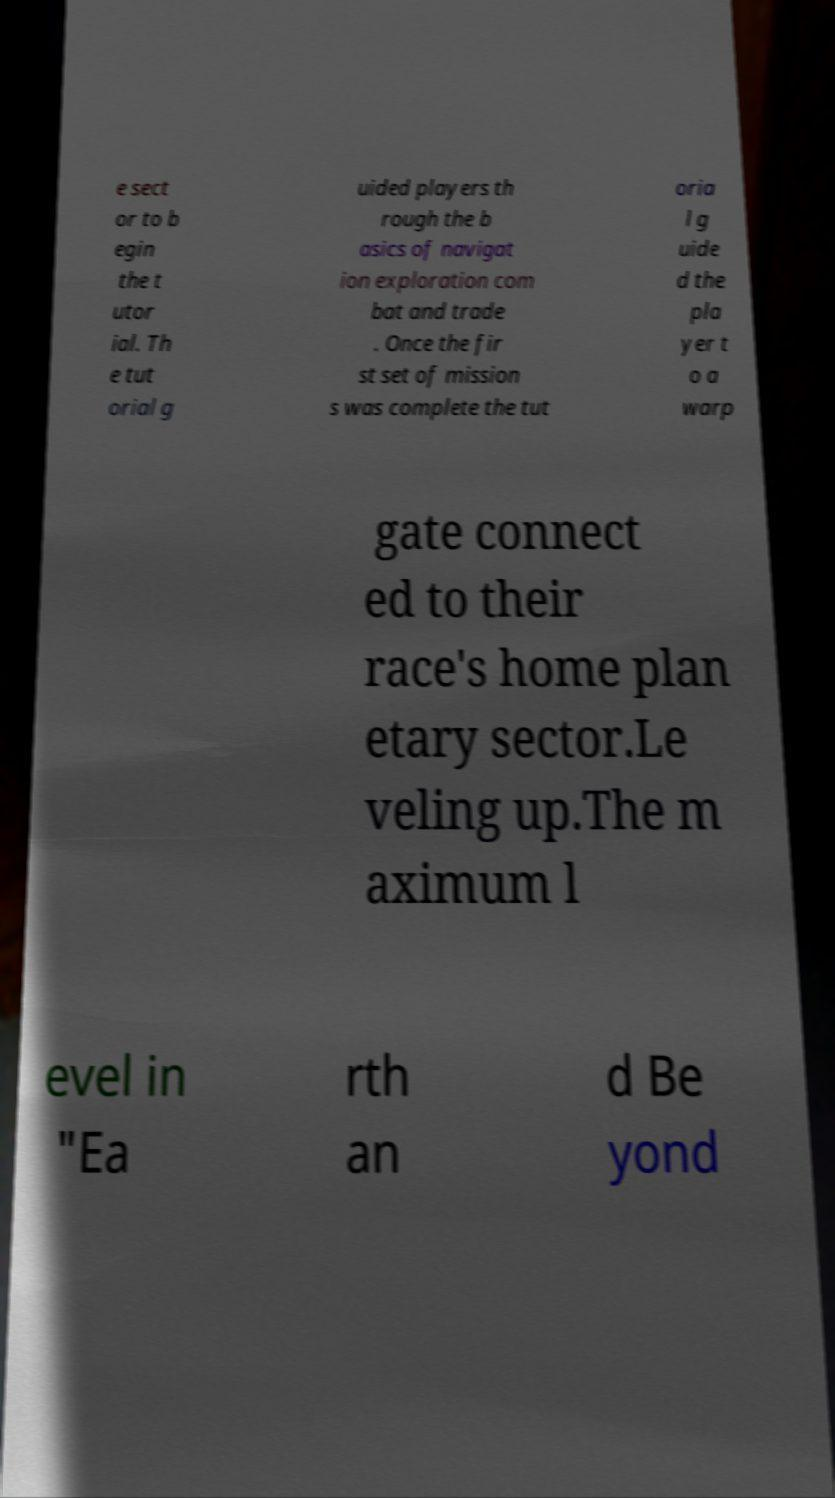I need the written content from this picture converted into text. Can you do that? e sect or to b egin the t utor ial. Th e tut orial g uided players th rough the b asics of navigat ion exploration com bat and trade . Once the fir st set of mission s was complete the tut oria l g uide d the pla yer t o a warp gate connect ed to their race's home plan etary sector.Le veling up.The m aximum l evel in "Ea rth an d Be yond 